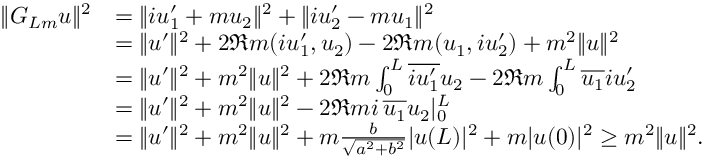Convert formula to latex. <formula><loc_0><loc_0><loc_500><loc_500>\begin{array} { r l } { \| G _ { L m } u \| ^ { 2 } } & { = \| i u _ { 1 } ^ { \prime } + m u _ { 2 } \| ^ { 2 } + \| i u _ { 2 } ^ { \prime } - m u _ { 1 } \| ^ { 2 } } \\ & { = \| u ^ { \prime } \| ^ { 2 } + 2 \Re m ( i u _ { 1 } ^ { \prime } , u _ { 2 } ) - 2 \Re m ( u _ { 1 } , i u _ { 2 } ^ { \prime } ) + m ^ { 2 } \| u \| ^ { 2 } } \\ & { = \| u ^ { \prime } \| ^ { 2 } + m ^ { 2 } \| u \| ^ { 2 } + 2 \Re m \int _ { 0 } ^ { L } \overline { { i u _ { 1 } ^ { \prime } } } u _ { 2 } - 2 \Re m \int _ { 0 } ^ { L } \overline { { u _ { 1 } } } i u _ { 2 } ^ { \prime } } \\ & { = \| u ^ { \prime } \| ^ { 2 } + m ^ { 2 } \| u \| ^ { 2 } - 2 \Re m i \, \overline { { u _ { 1 } } } u _ { 2 } | _ { 0 } ^ { L } } \\ & { = \| u ^ { \prime } \| ^ { 2 } + m ^ { 2 } \| u \| ^ { 2 } + m \frac { b } { \sqrt { a ^ { 2 } + b ^ { 2 } } } | u ( L ) | ^ { 2 } + m | u ( 0 ) | ^ { 2 } \geq m ^ { 2 } \| u \| ^ { 2 } . } \end{array}</formula> 